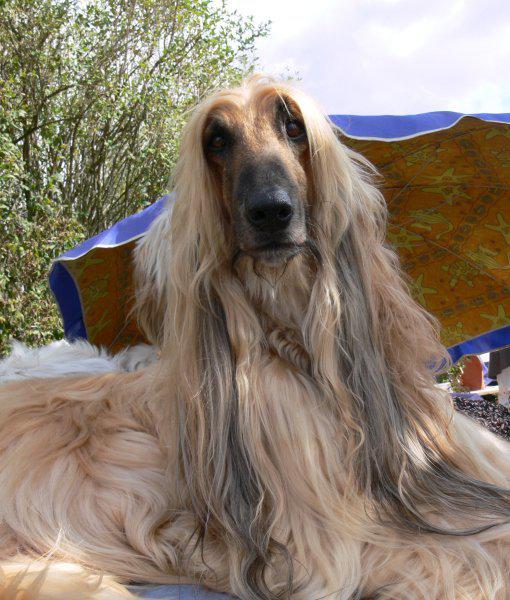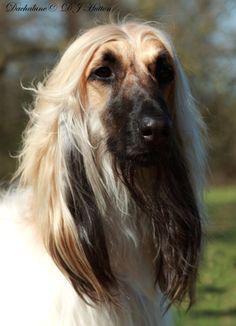The first image is the image on the left, the second image is the image on the right. Given the left and right images, does the statement "All images contain afghan dogs with black snouts." hold true? Answer yes or no. Yes. 